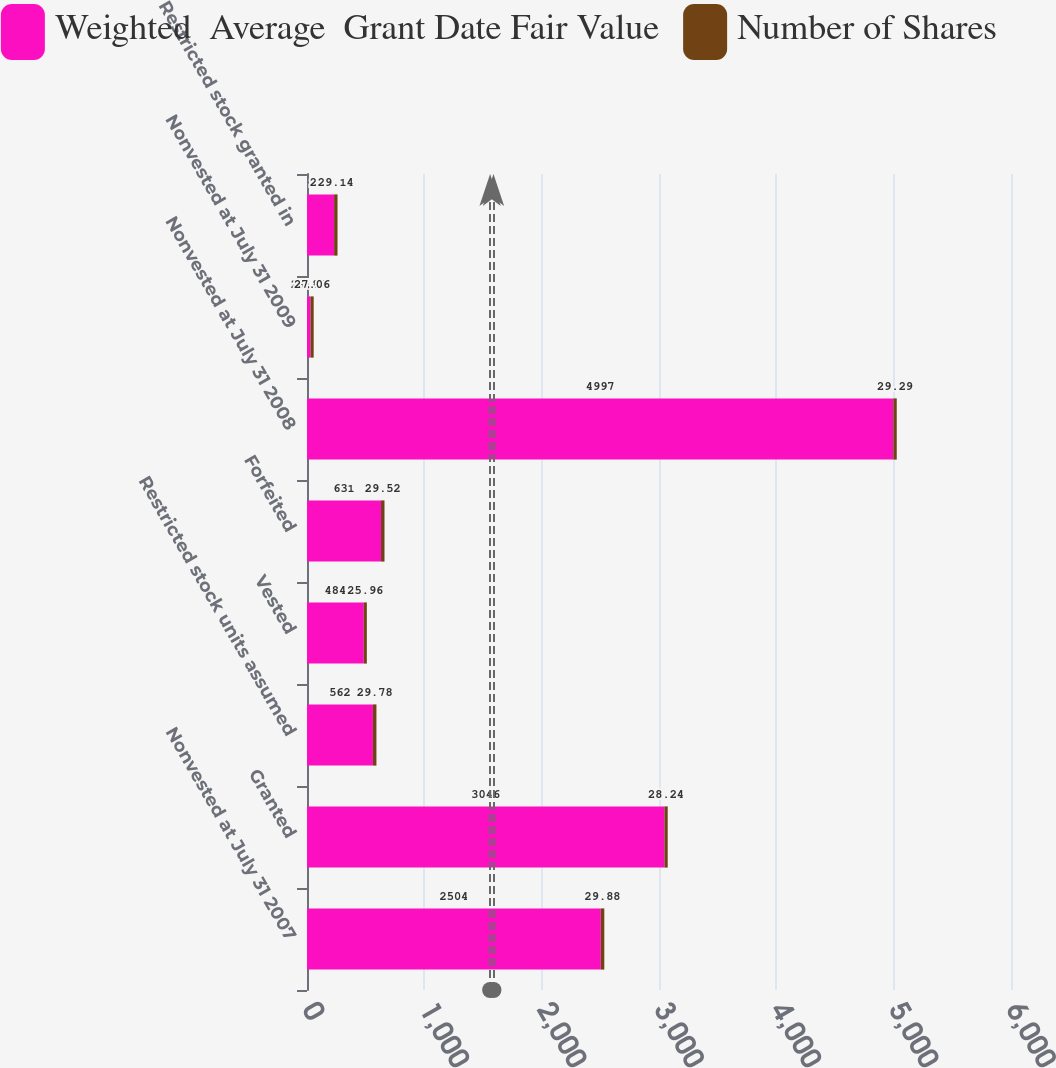Convert chart to OTSL. <chart><loc_0><loc_0><loc_500><loc_500><stacked_bar_chart><ecel><fcel>Nonvested at July 31 2007<fcel>Granted<fcel>Restricted stock units assumed<fcel>Vested<fcel>Forfeited<fcel>Nonvested at July 31 2008<fcel>Nonvested at July 31 2009<fcel>Restricted stock granted in<nl><fcel>Weighted  Average  Grant Date Fair Value<fcel>2504<fcel>3046<fcel>562<fcel>484<fcel>631<fcel>4997<fcel>29.88<fcel>231<nl><fcel>Number of Shares<fcel>29.88<fcel>28.24<fcel>29.78<fcel>25.96<fcel>29.52<fcel>29.29<fcel>27.06<fcel>29.14<nl></chart> 